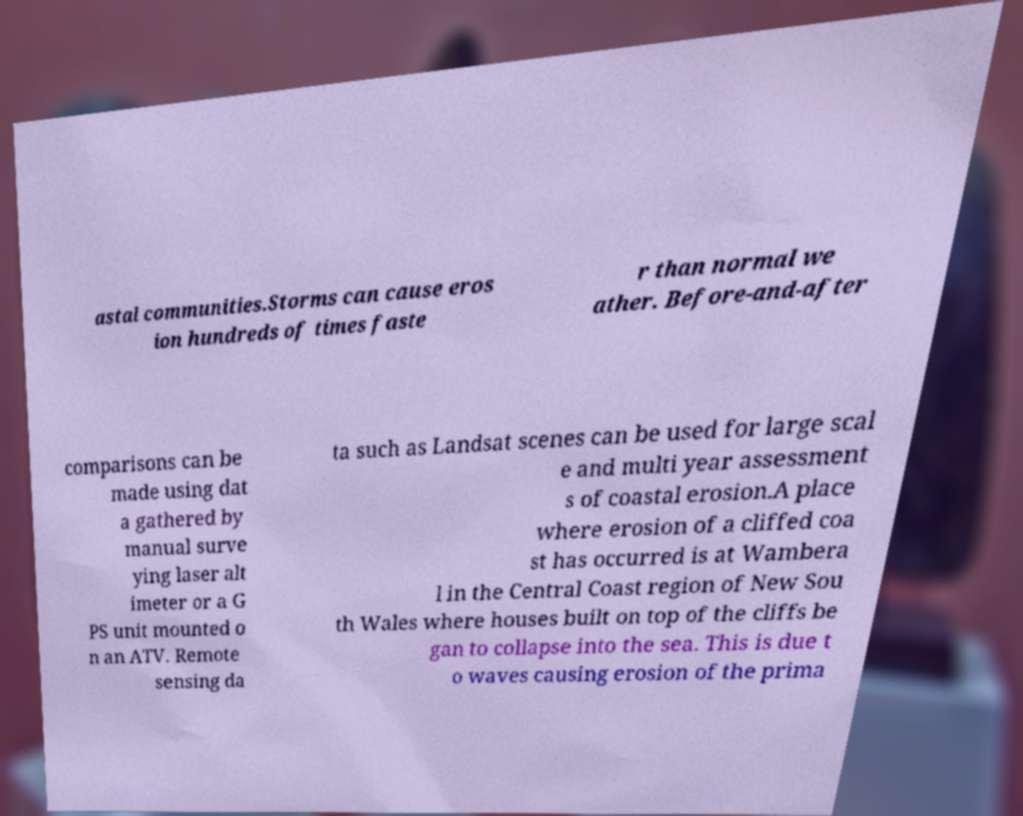What messages or text are displayed in this image? I need them in a readable, typed format. astal communities.Storms can cause eros ion hundreds of times faste r than normal we ather. Before-and-after comparisons can be made using dat a gathered by manual surve ying laser alt imeter or a G PS unit mounted o n an ATV. Remote sensing da ta such as Landsat scenes can be used for large scal e and multi year assessment s of coastal erosion.A place where erosion of a cliffed coa st has occurred is at Wambera l in the Central Coast region of New Sou th Wales where houses built on top of the cliffs be gan to collapse into the sea. This is due t o waves causing erosion of the prima 